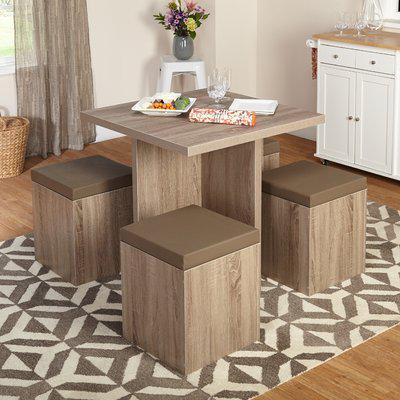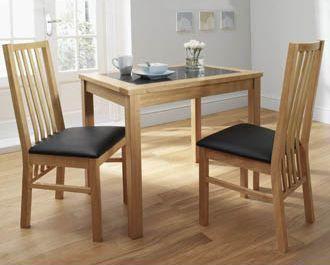The first image is the image on the left, the second image is the image on the right. Analyze the images presented: Is the assertion "One image shows a brown topped white table with six white chairs with brown seats around it, and the other image shows a non-round table with a bench on one side and at least three chairs with multiple rails across the back." valid? Answer yes or no. No. The first image is the image on the left, the second image is the image on the right. Considering the images on both sides, is "In one of the images, two different styles of seating are available around a single table." valid? Answer yes or no. No. 